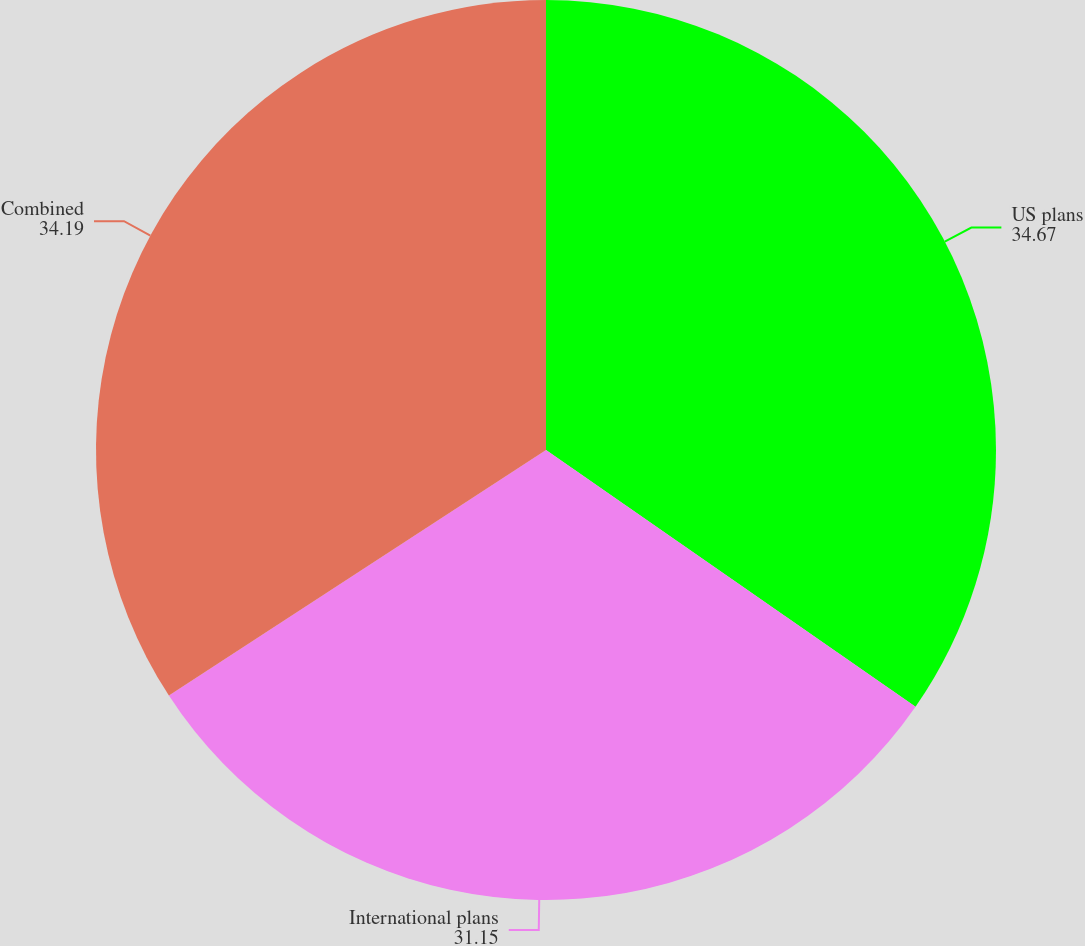<chart> <loc_0><loc_0><loc_500><loc_500><pie_chart><fcel>US plans<fcel>International plans<fcel>Combined<nl><fcel>34.67%<fcel>31.15%<fcel>34.19%<nl></chart> 